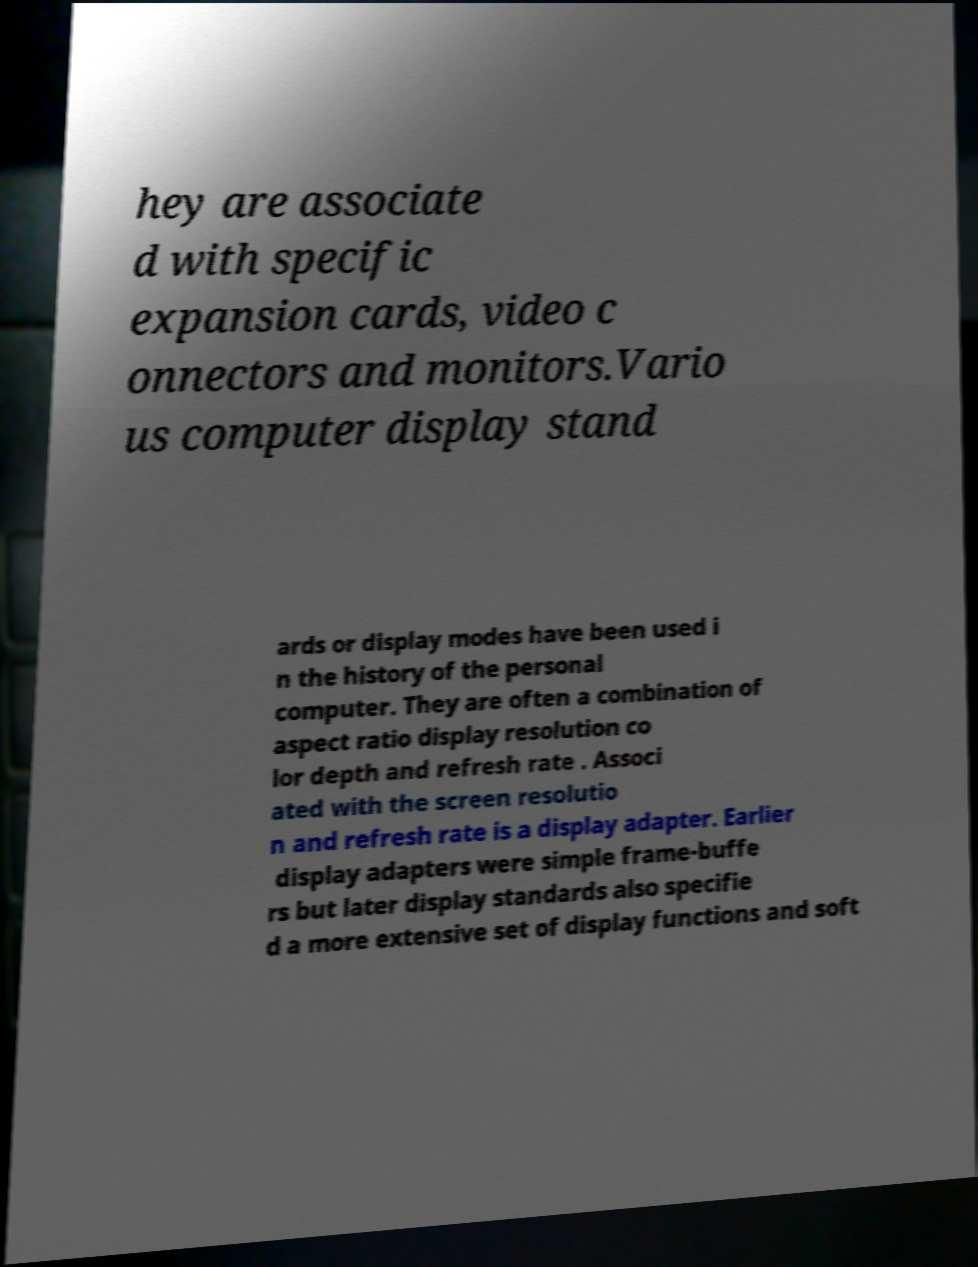Could you extract and type out the text from this image? hey are associate d with specific expansion cards, video c onnectors and monitors.Vario us computer display stand ards or display modes have been used i n the history of the personal computer. They are often a combination of aspect ratio display resolution co lor depth and refresh rate . Associ ated with the screen resolutio n and refresh rate is a display adapter. Earlier display adapters were simple frame-buffe rs but later display standards also specifie d a more extensive set of display functions and soft 